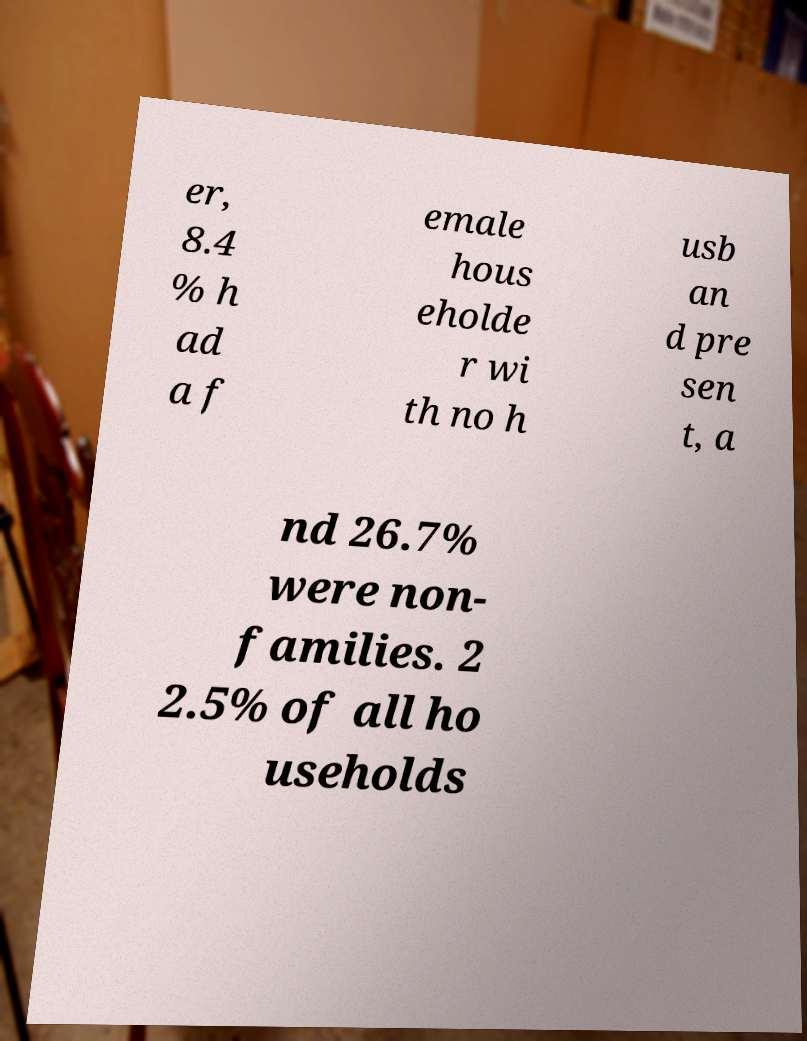What messages or text are displayed in this image? I need them in a readable, typed format. er, 8.4 % h ad a f emale hous eholde r wi th no h usb an d pre sen t, a nd 26.7% were non- families. 2 2.5% of all ho useholds 